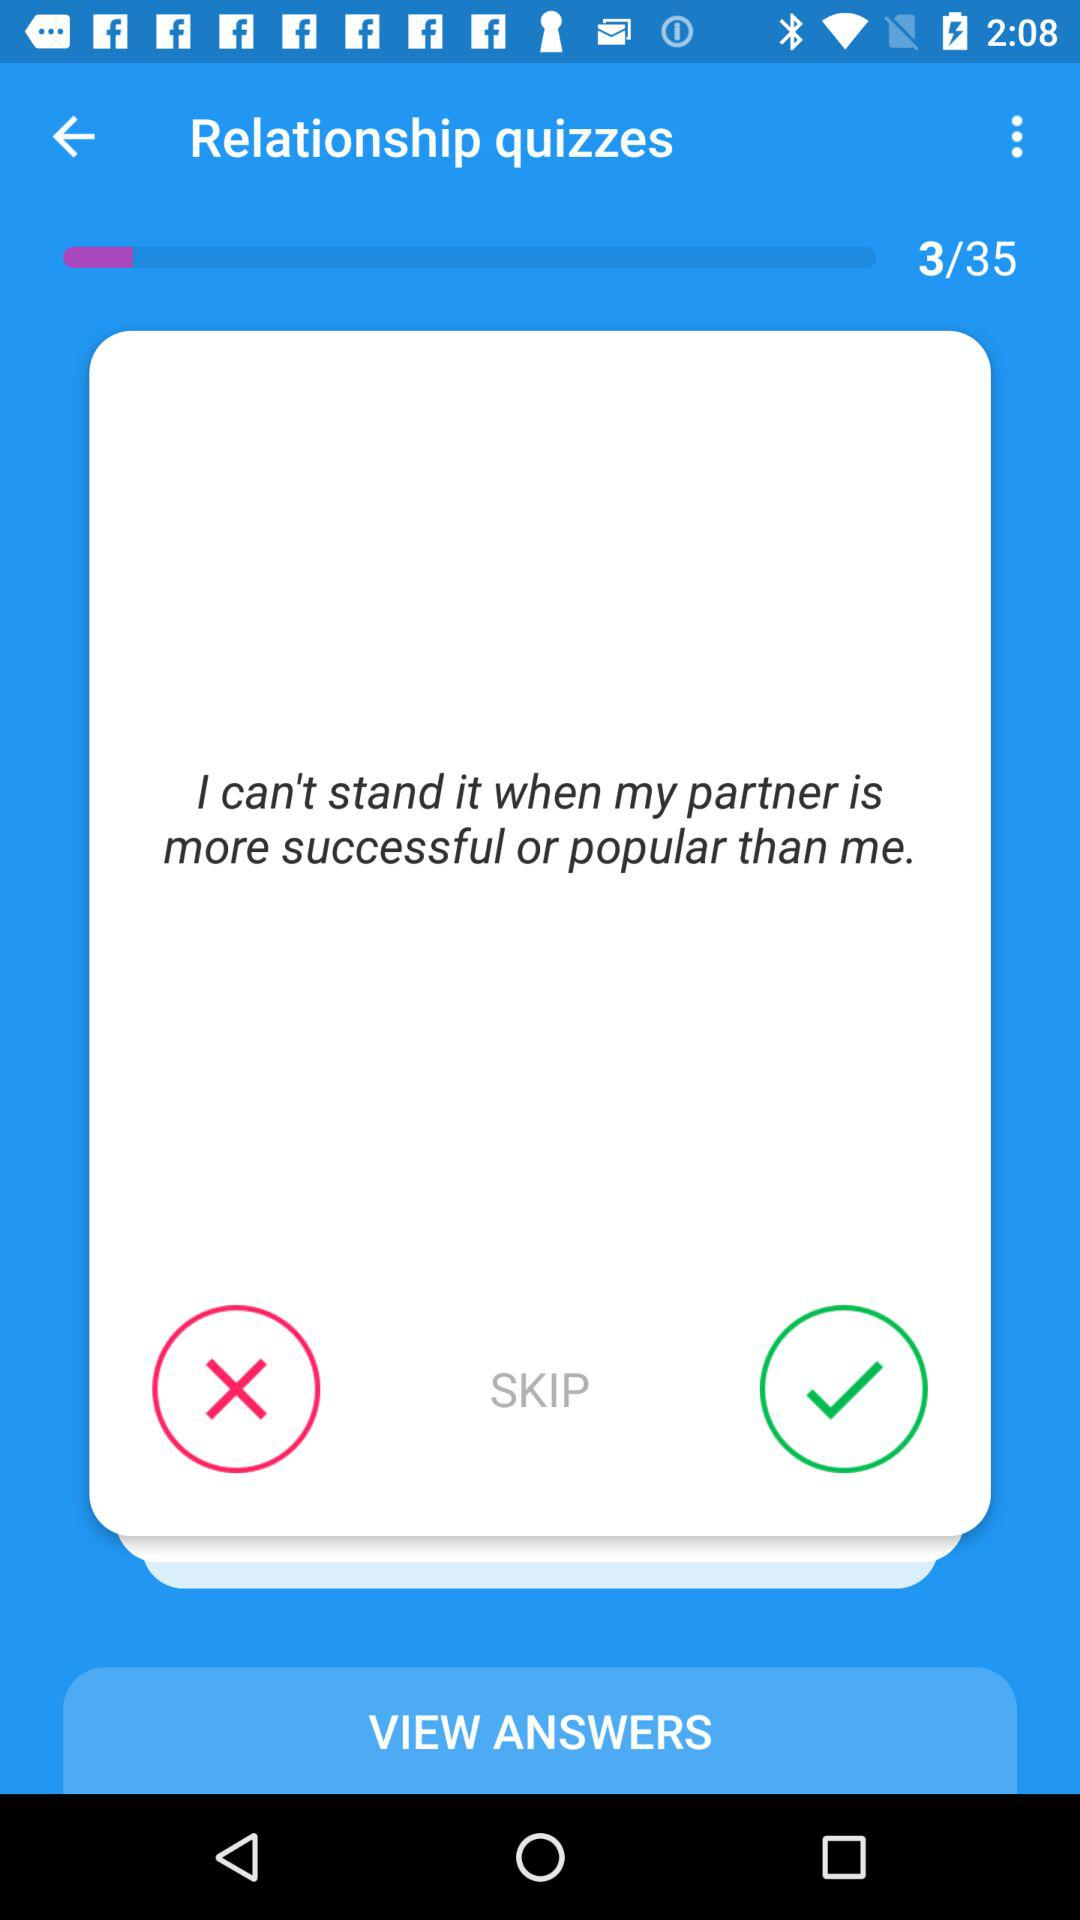How many questions in total are there in the quiz? There are total 35 questions. 